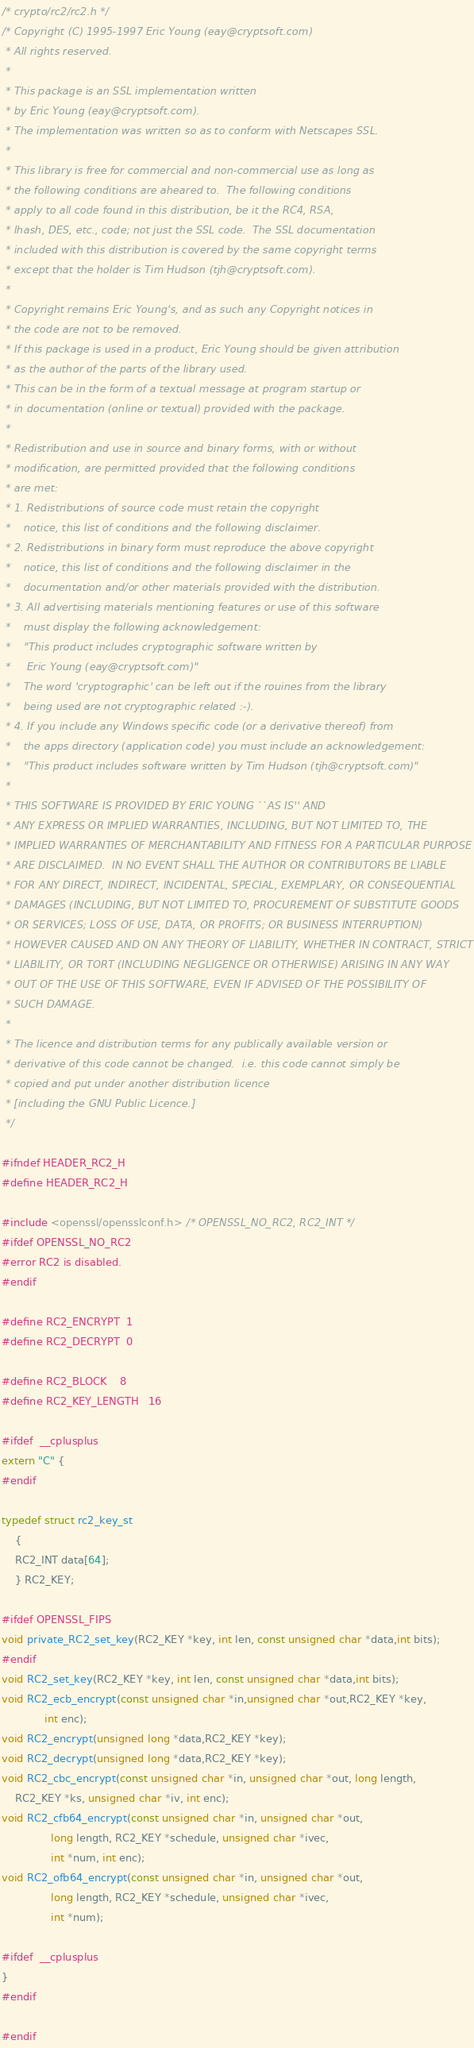<code> <loc_0><loc_0><loc_500><loc_500><_C_>/* crypto/rc2/rc2.h */
/* Copyright (C) 1995-1997 Eric Young (eay@cryptsoft.com)
 * All rights reserved.
 *
 * This package is an SSL implementation written
 * by Eric Young (eay@cryptsoft.com).
 * The implementation was written so as to conform with Netscapes SSL.
 * 
 * This library is free for commercial and non-commercial use as long as
 * the following conditions are aheared to.  The following conditions
 * apply to all code found in this distribution, be it the RC4, RSA,
 * lhash, DES, etc., code; not just the SSL code.  The SSL documentation
 * included with this distribution is covered by the same copyright terms
 * except that the holder is Tim Hudson (tjh@cryptsoft.com).
 * 
 * Copyright remains Eric Young's, and as such any Copyright notices in
 * the code are not to be removed.
 * If this package is used in a product, Eric Young should be given attribution
 * as the author of the parts of the library used.
 * This can be in the form of a textual message at program startup or
 * in documentation (online or textual) provided with the package.
 * 
 * Redistribution and use in source and binary forms, with or without
 * modification, are permitted provided that the following conditions
 * are met:
 * 1. Redistributions of source code must retain the copyright
 *    notice, this list of conditions and the following disclaimer.
 * 2. Redistributions in binary form must reproduce the above copyright
 *    notice, this list of conditions and the following disclaimer in the
 *    documentation and/or other materials provided with the distribution.
 * 3. All advertising materials mentioning features or use of this software
 *    must display the following acknowledgement:
 *    "This product includes cryptographic software written by
 *     Eric Young (eay@cryptsoft.com)"
 *    The word 'cryptographic' can be left out if the rouines from the library
 *    being used are not cryptographic related :-).
 * 4. If you include any Windows specific code (or a derivative thereof) from 
 *    the apps directory (application code) you must include an acknowledgement:
 *    "This product includes software written by Tim Hudson (tjh@cryptsoft.com)"
 * 
 * THIS SOFTWARE IS PROVIDED BY ERIC YOUNG ``AS IS'' AND
 * ANY EXPRESS OR IMPLIED WARRANTIES, INCLUDING, BUT NOT LIMITED TO, THE
 * IMPLIED WARRANTIES OF MERCHANTABILITY AND FITNESS FOR A PARTICULAR PURPOSE
 * ARE DISCLAIMED.  IN NO EVENT SHALL THE AUTHOR OR CONTRIBUTORS BE LIABLE
 * FOR ANY DIRECT, INDIRECT, INCIDENTAL, SPECIAL, EXEMPLARY, OR CONSEQUENTIAL
 * DAMAGES (INCLUDING, BUT NOT LIMITED TO, PROCUREMENT OF SUBSTITUTE GOODS
 * OR SERVICES; LOSS OF USE, DATA, OR PROFITS; OR BUSINESS INTERRUPTION)
 * HOWEVER CAUSED AND ON ANY THEORY OF LIABILITY, WHETHER IN CONTRACT, STRICT
 * LIABILITY, OR TORT (INCLUDING NEGLIGENCE OR OTHERWISE) ARISING IN ANY WAY
 * OUT OF THE USE OF THIS SOFTWARE, EVEN IF ADVISED OF THE POSSIBILITY OF
 * SUCH DAMAGE.
 * 
 * The licence and distribution terms for any publically available version or
 * derivative of this code cannot be changed.  i.e. this code cannot simply be
 * copied and put under another distribution licence
 * [including the GNU Public Licence.]
 */

#ifndef HEADER_RC2_H
#define HEADER_RC2_H

#include <openssl/opensslconf.h> /* OPENSSL_NO_RC2, RC2_INT */
#ifdef OPENSSL_NO_RC2
#error RC2 is disabled.
#endif

#define RC2_ENCRYPT	1
#define RC2_DECRYPT	0

#define RC2_BLOCK	8
#define RC2_KEY_LENGTH	16

#ifdef  __cplusplus
extern "C" {
#endif

typedef struct rc2_key_st
	{
	RC2_INT data[64];
	} RC2_KEY;

#ifdef OPENSSL_FIPS 
void private_RC2_set_key(RC2_KEY *key, int len, const unsigned char *data,int bits);
#endif
void RC2_set_key(RC2_KEY *key, int len, const unsigned char *data,int bits);
void RC2_ecb_encrypt(const unsigned char *in,unsigned char *out,RC2_KEY *key,
		     int enc);
void RC2_encrypt(unsigned long *data,RC2_KEY *key);
void RC2_decrypt(unsigned long *data,RC2_KEY *key);
void RC2_cbc_encrypt(const unsigned char *in, unsigned char *out, long length,
	RC2_KEY *ks, unsigned char *iv, int enc);
void RC2_cfb64_encrypt(const unsigned char *in, unsigned char *out,
		       long length, RC2_KEY *schedule, unsigned char *ivec,
		       int *num, int enc);
void RC2_ofb64_encrypt(const unsigned char *in, unsigned char *out,
		       long length, RC2_KEY *schedule, unsigned char *ivec,
		       int *num);

#ifdef  __cplusplus
}
#endif

#endif
</code> 